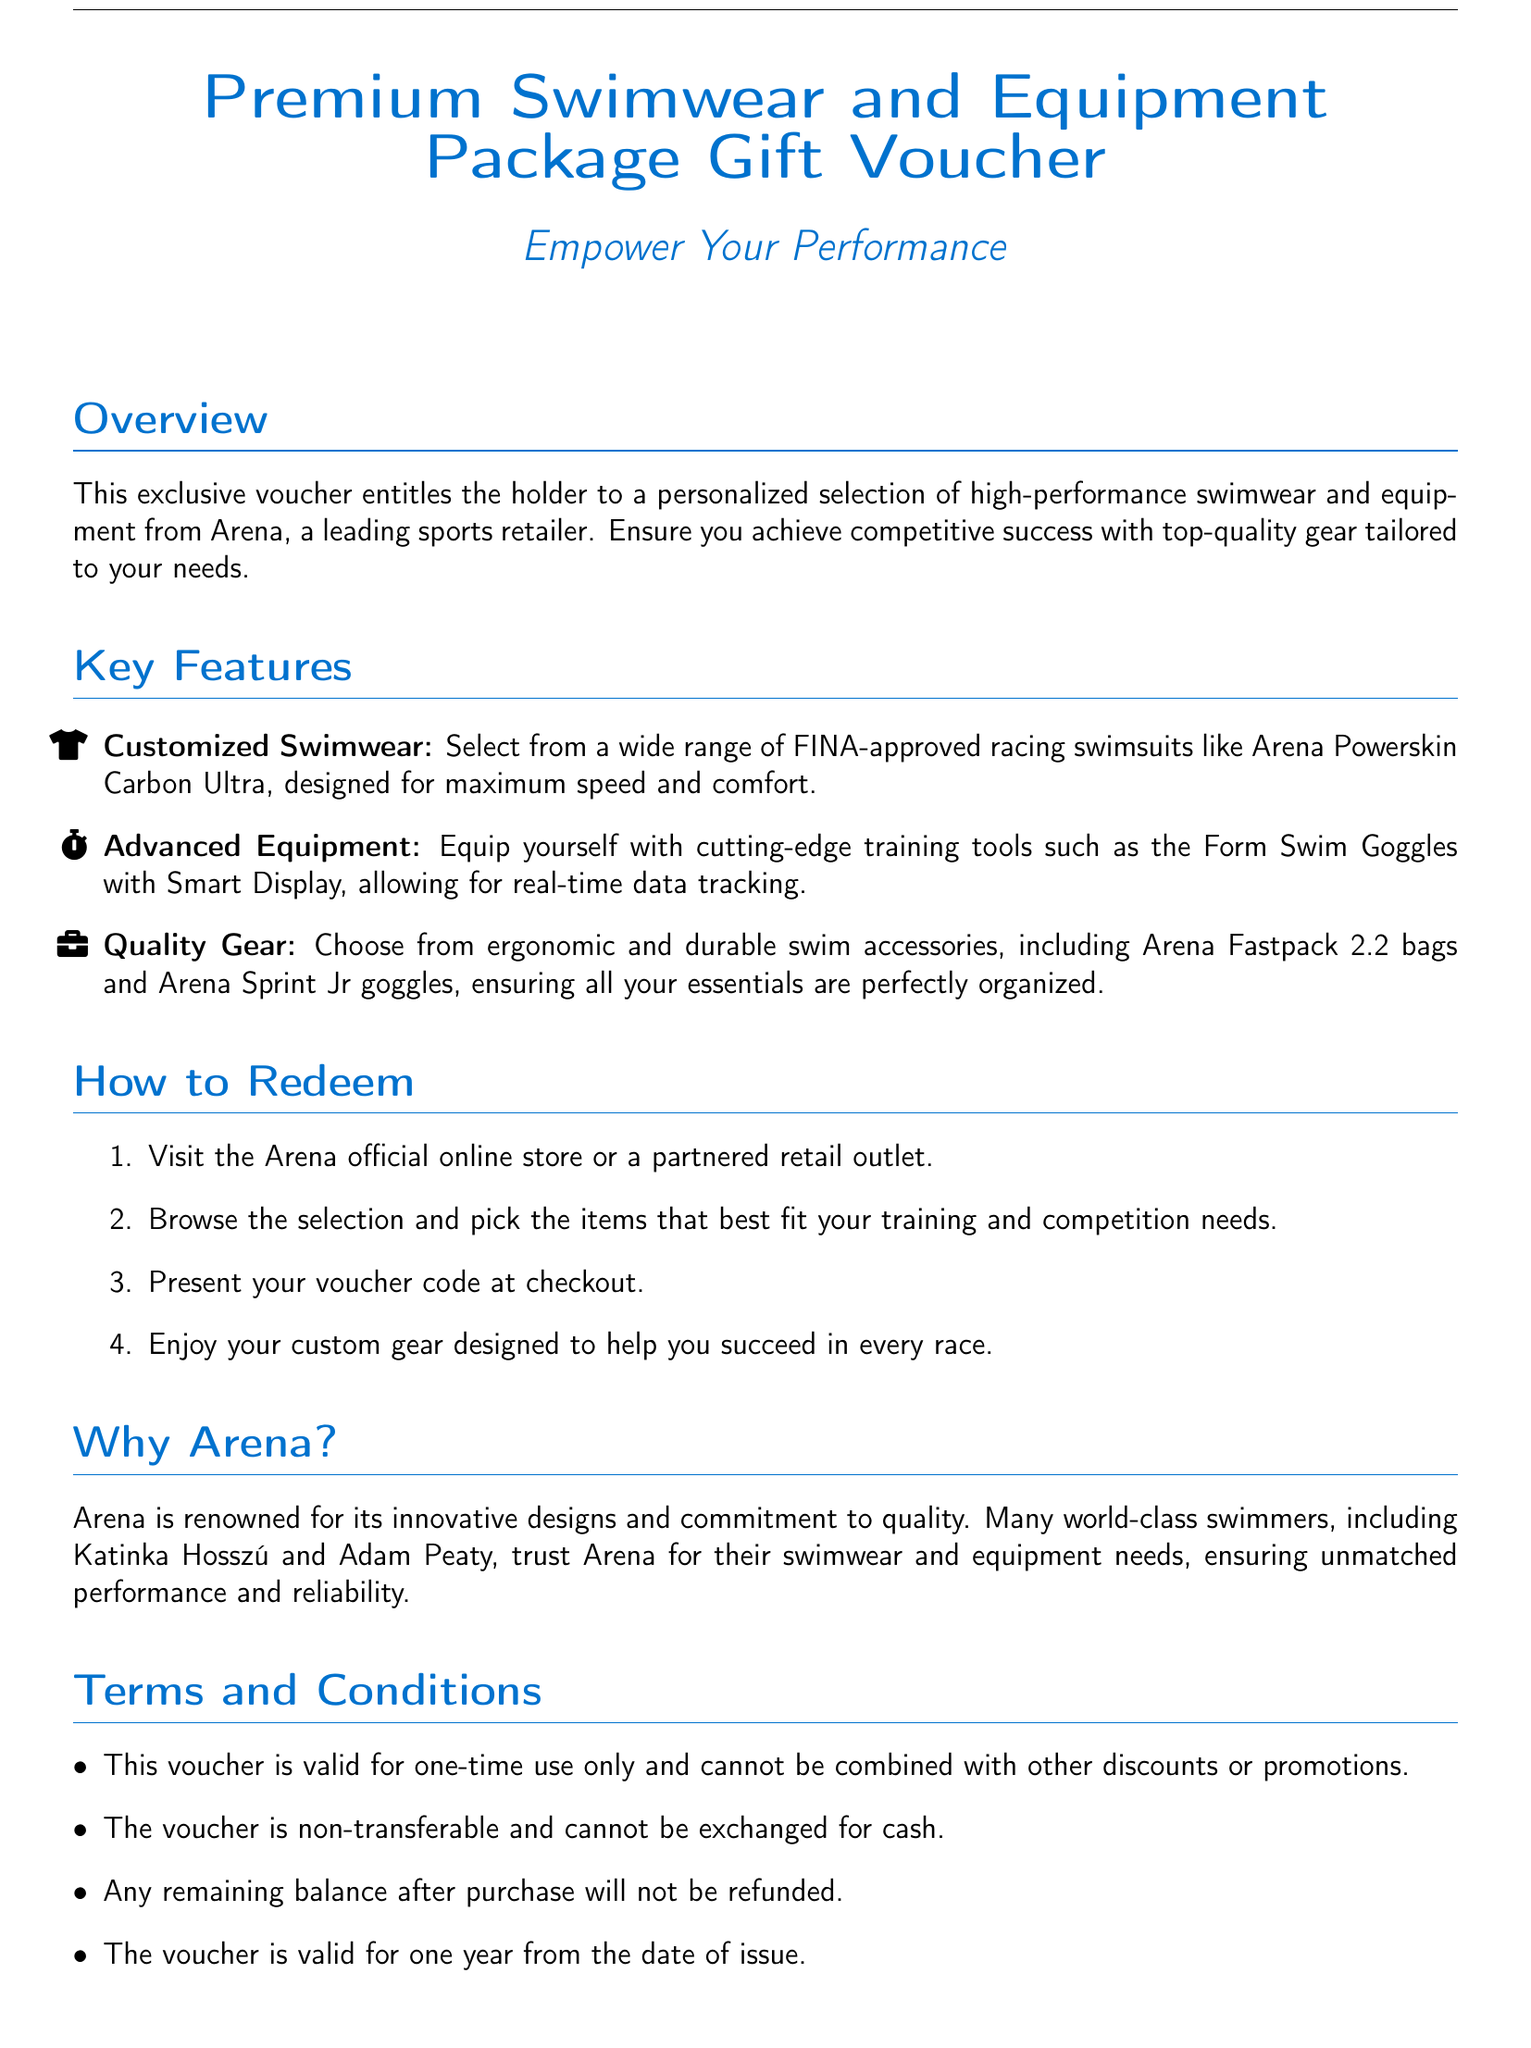What is the name of the top-quality swimwear brand featured in the voucher? The document specifies that the swimwear is from Arena, a leading sports retailer.
Answer: Arena How many key features are mentioned in the document? The document lists three key features regarding the swimwear and equipment package.
Answer: Three What is the duration of validity for the voucher? The terms and conditions state that the voucher is valid for one year from the date of issue.
Answer: One year What type of swimwear is included in the "Customized Swimwear" feature? The document mentions that you can select FINA-approved racing swimsuits.
Answer: FINA-approved racing swimsuits What is required to redeem the voucher at checkout? The document states that you must present your voucher code at checkout.
Answer: Voucher code Who are some of the world-class swimmers that trust Arena for their gear? The document mentions Katinka Hosszú and Adam Peaty as athletes trusting Arena.
Answer: Katinka Hosszú and Adam Peaty What is the contact email provided for inquiries? The document includes the email address support@arena.com for customer inquiries.
Answer: support@arena.com Is the voucher transferable to another person? The terms and conditions indicate that the voucher is non-transferable.
Answer: Non-transferable 